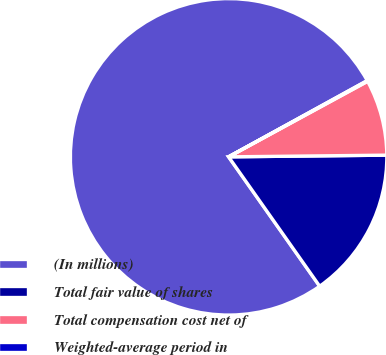Convert chart to OTSL. <chart><loc_0><loc_0><loc_500><loc_500><pie_chart><fcel>(In millions)<fcel>Total fair value of shares<fcel>Total compensation cost net of<fcel>Weighted-average period in<nl><fcel>76.76%<fcel>15.41%<fcel>7.75%<fcel>0.08%<nl></chart> 